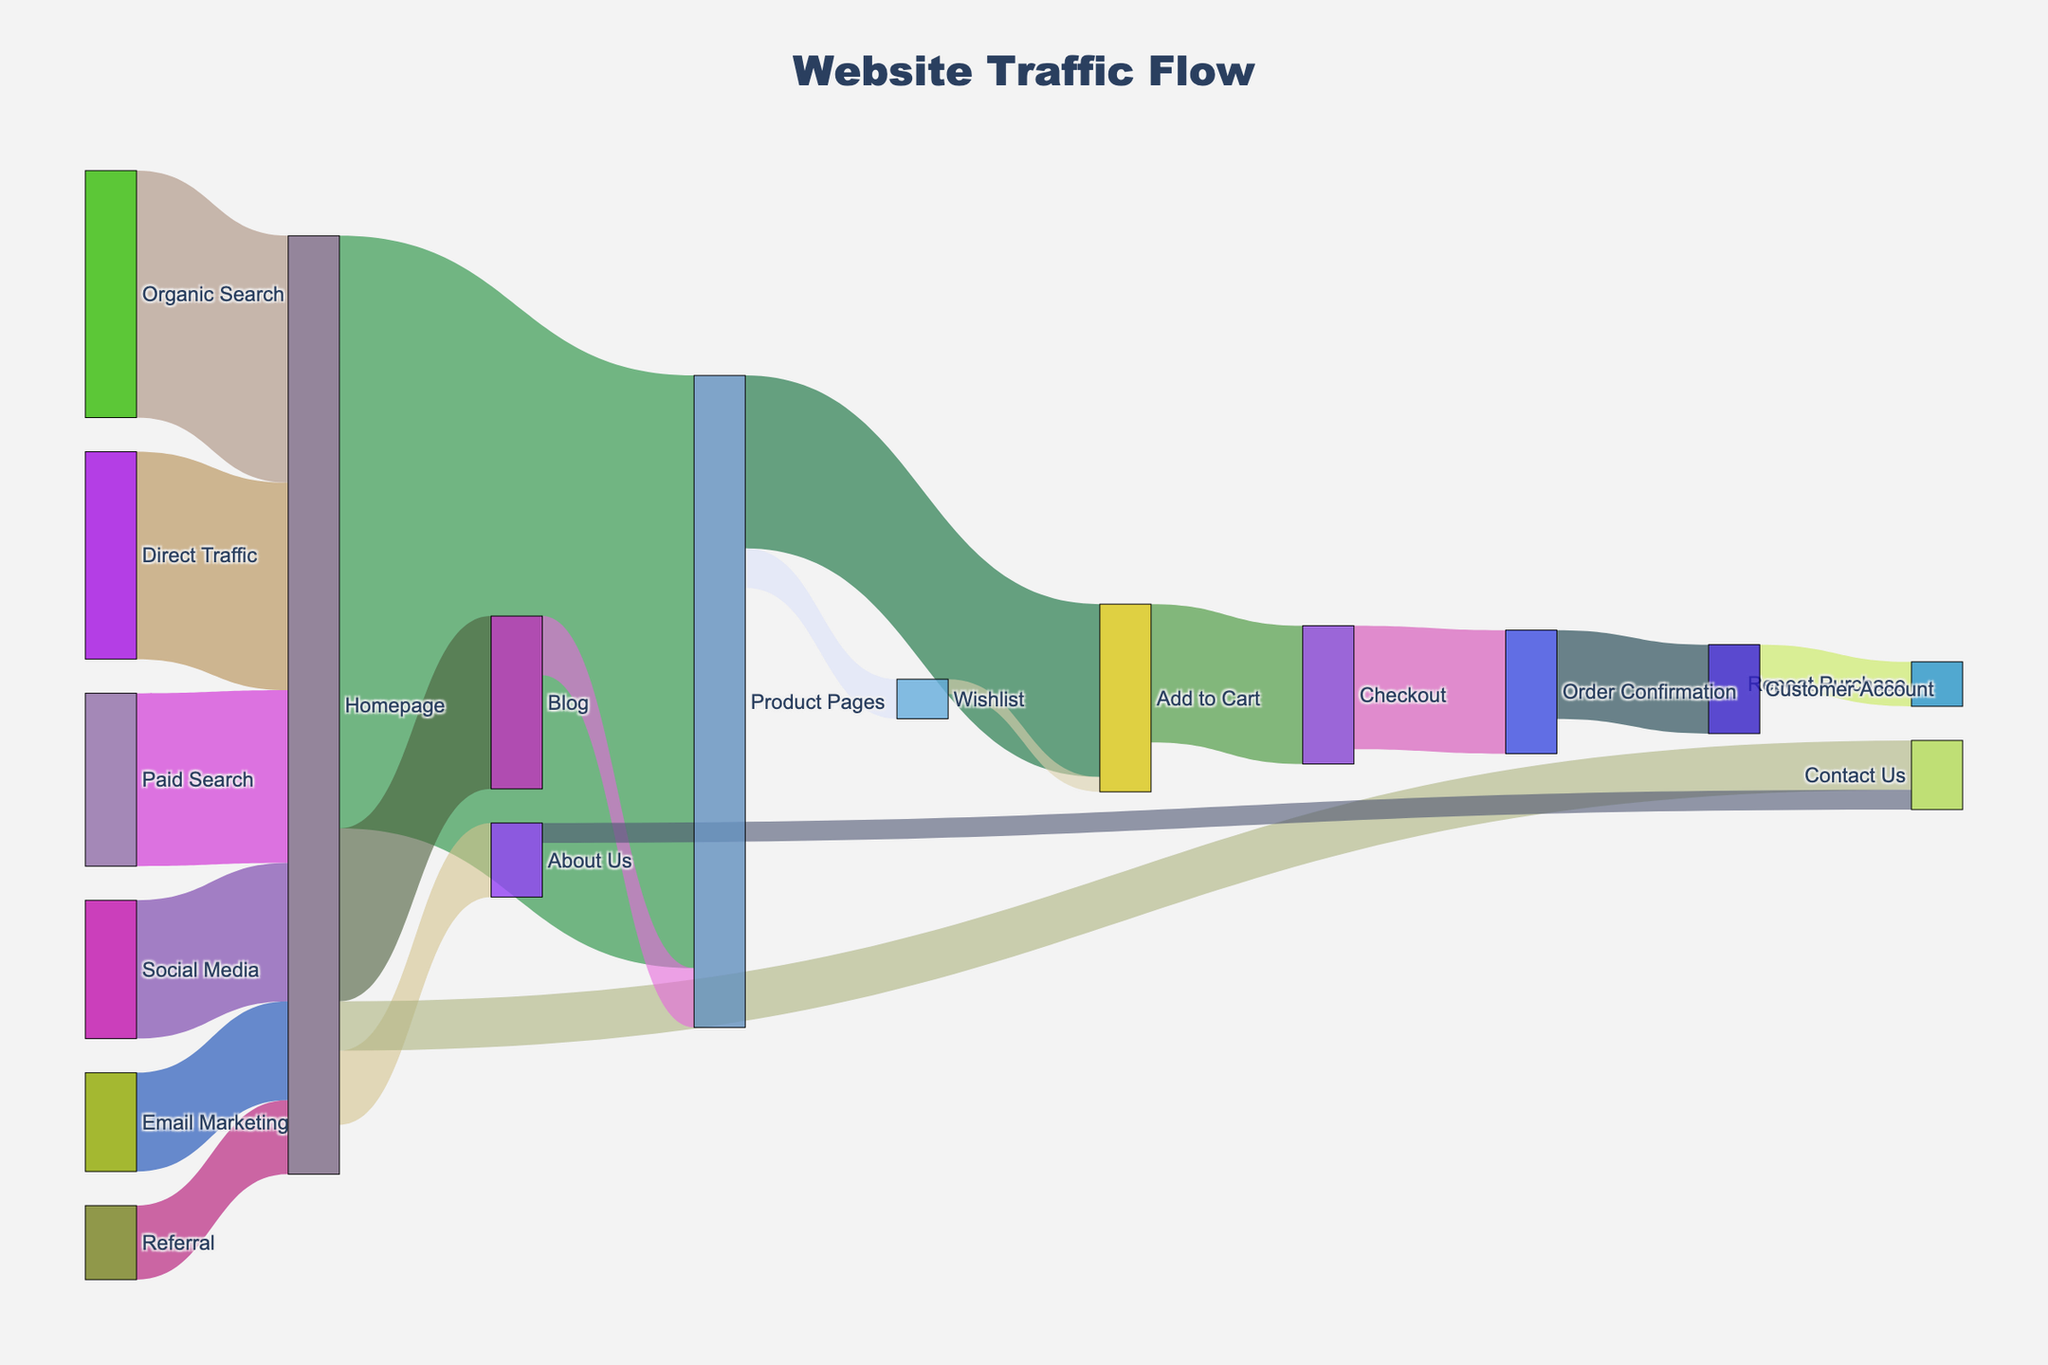What's the most common source of traffic on the homepage? Identify the visual paths in the Sankey diagram and compare the flows leading to the homepage. The Organic Search has the highest value among the sources leading to the Homepage.
Answer: Organic Search Which section of the site has the second highest traffic from the homepage? Look at the flows emanating from the homepage and compare their values. The second highest value flow from the Homepage is to the Blog.
Answer: Blog How much total traffic reaches the Product Pages from all sources? Sum all the values leading to Product Pages. From the Homepage to Product Pages is 12000 and from the Blog to Product Pages is 1200. Total = 12000 + 1200 = 13200.
Answer: 13200 How does the traffic to 'About Us' compare to 'Contact Us' from the Homepage? Compare the values of the flows from Homepage to 'About Us' and 'Contact Us'. The Homepage to 'About Us' has 1500 while the Homepage to 'Contact Us' has 1000.
Answer: About Us has more traffic Which conversion point has the highest drop-off rate from their prior stage? Identify the flows leading to conversion points and count how many did not proceed to the next stage. Checkout to Order Confirmation drop-off is 300 (2800 - 2500).
Answer: Checkout to Order Confirmation What is the total traffic that leads to Order Confirmation from the Homepage? Follow the paths from Homepage to 'Order Confirmation', sum up the values on the way to Order Confirmation. Homepage to Product Pages (12000) to Add to Cart (3500) to Checkout (2800) to Order Confirmation (2500). Traffic from the Homepage contributing towards Order Confirmation is 2500.
Answer: 2500 What percentage of Direct Traffic ends up in Repeat Purchase? Identify Direct Traffic to Homepage (4200), flow to Repeat Purchase is 900. Calculate percentage: (900/4200) x 100 = 21.43%
Answer: 21.4% How do Email Marketing and Referral compare in their contribution to Homepage traffic? Compare values leading homeowners from Email Marketing and Referral. Email Marketing is 2000 and Referral is 1500. Email Marketing generates more traffic to the Homepage.
Answer: Email Marketing generates more Which section on the website has the least traffic from the Homepage? Compare the values of the flows from Homepage to different sections. Contact Us has the least traffic from Homepage with 1000.
Answer: Contact Us How does the traffic flow from Social Media to the Website end up being distributed across various sections? Identify the values flow from the Social Media to the Homepage (2800) and then trace each path from the Homepage to other sections. Sum flows to Product Pages (12000), Blog (3500), and others, proportion of Social Media calculated divided amongst these sections. Majority traffic leads to Product Pages (12000/2800).
Answer: Predominantly Product Pages 